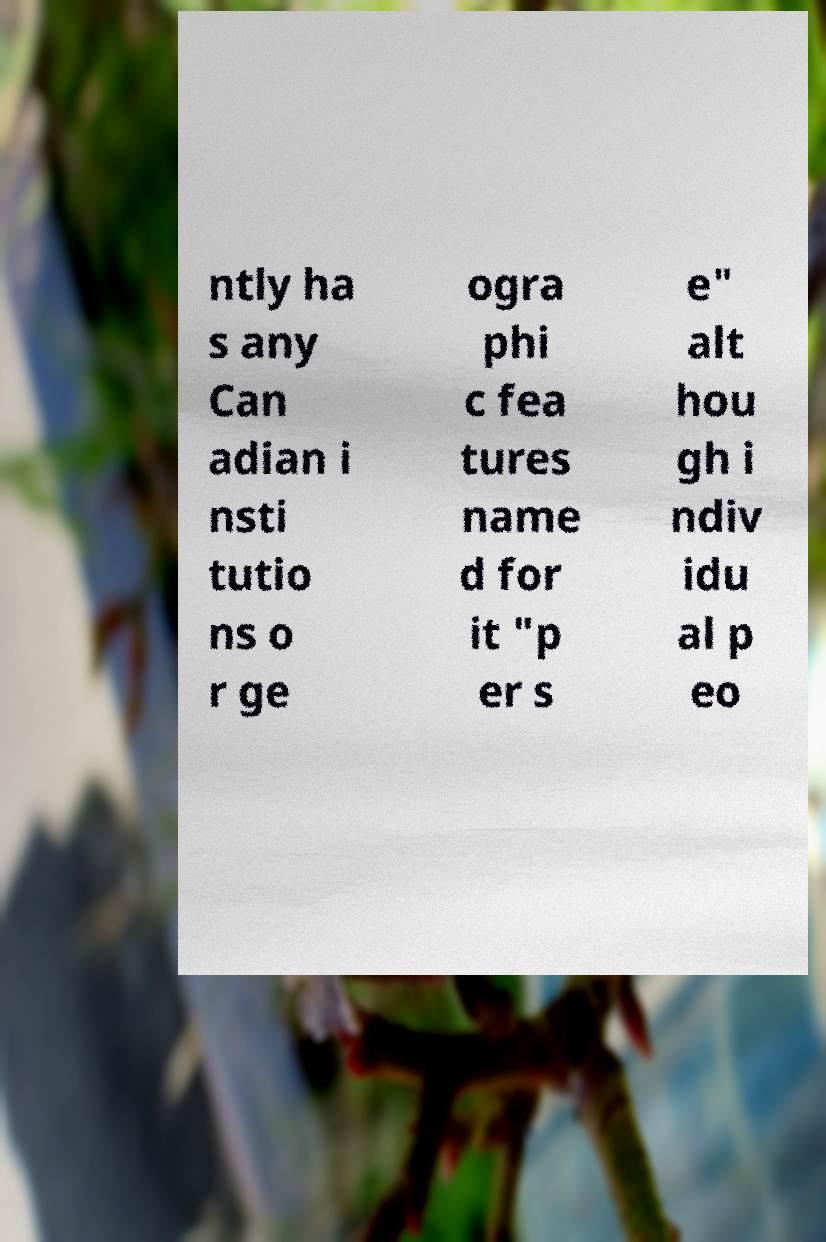Please read and relay the text visible in this image. What does it say? ntly ha s any Can adian i nsti tutio ns o r ge ogra phi c fea tures name d for it "p er s e" alt hou gh i ndiv idu al p eo 